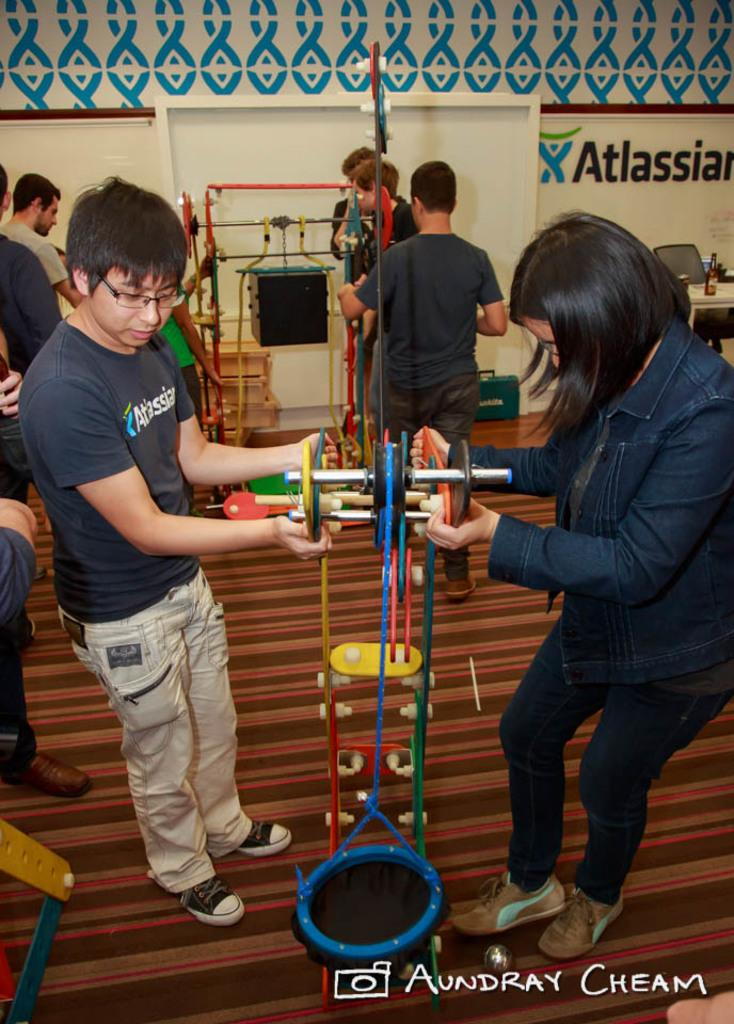How many people are visible in the image? There are two persons standing in the image. What are the two persons doing in the image? The two persons are holding an object between them. Can you describe the background of the image? There are other people in the background of the image. What type of trucks can be seen in the scene? There are no trucks present in the image; it only features two persons holding an object and other people in the background. 